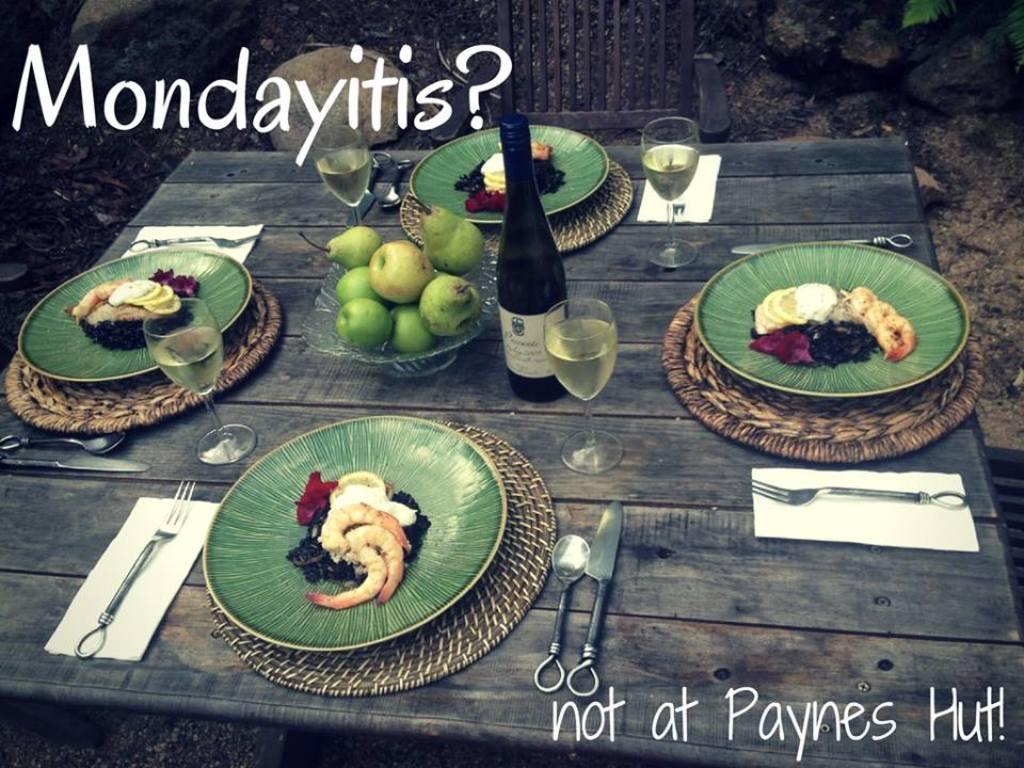Please provide a concise description of this image. In this image I can see few food items in the plates and I can also see few bottles, glasses on the table and I can see something written on the image. 